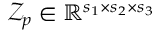<formula> <loc_0><loc_0><loc_500><loc_500>\mathcal { Z } _ { p } \in \mathbb { R } ^ { s _ { 1 } \times s _ { 2 } \times s _ { 3 } }</formula> 